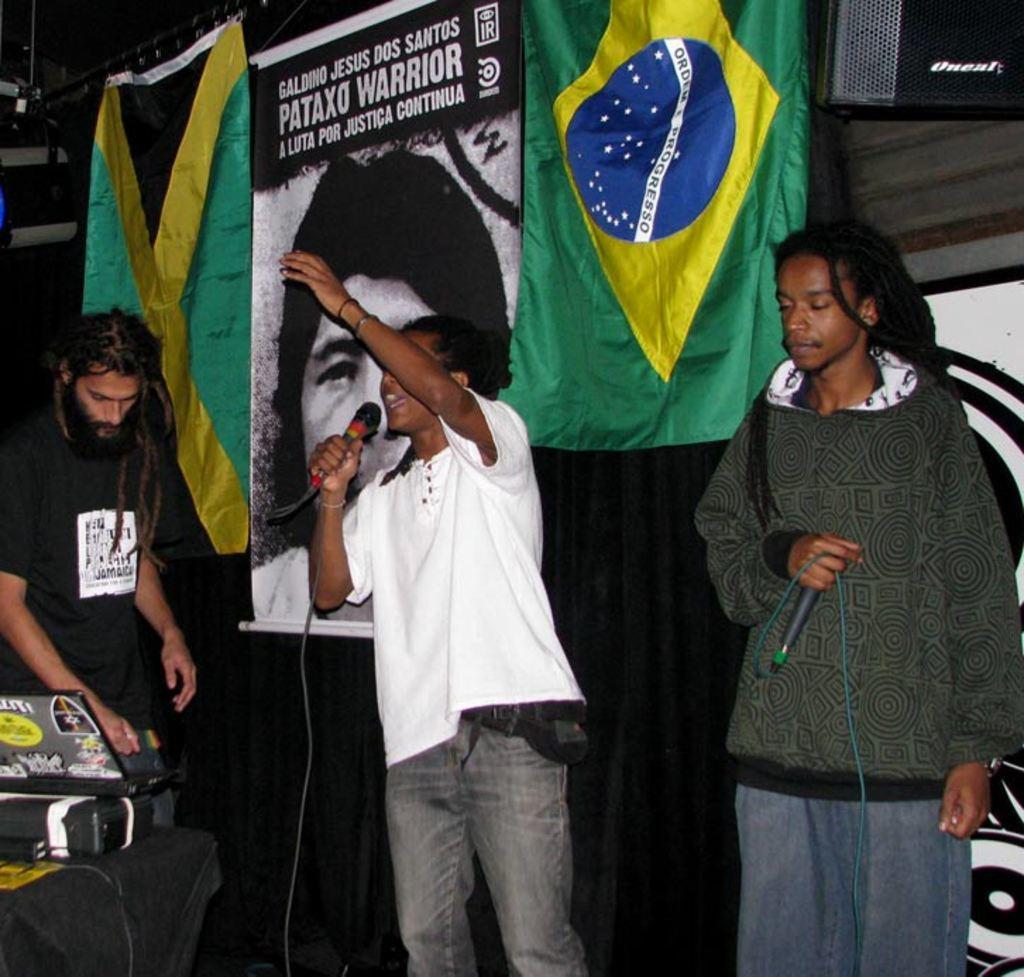Could you give a brief overview of what you see in this image? In this picture we can see the two persons holding microphones and standing. On the left we can see a man wearing black color t-shirt and seems to be standing and we can see a laptop and some other object is placed on top of the table. In the background we can see the cloth and the text and some picture of a person on the banner and we can see some other objects. 